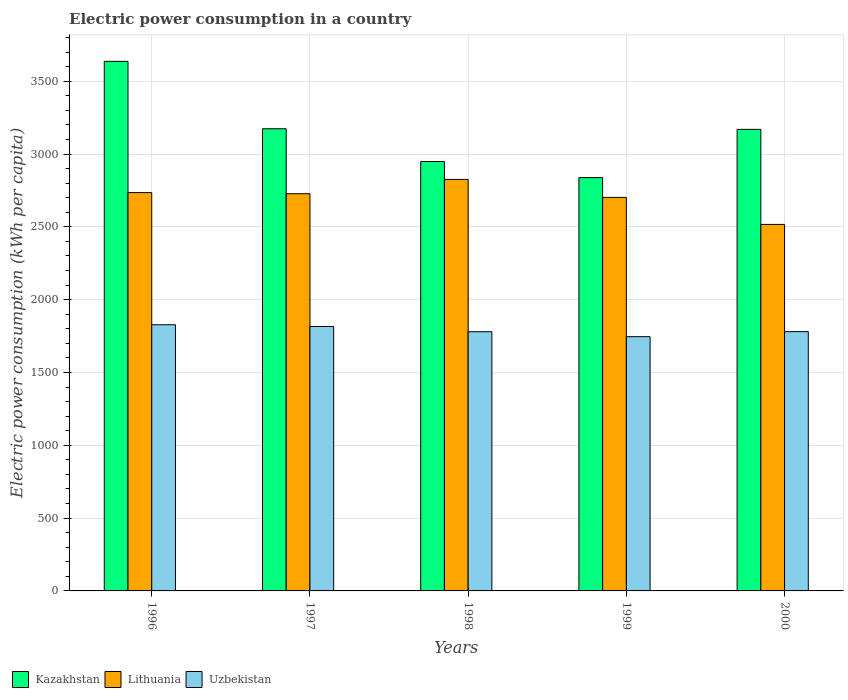How many different coloured bars are there?
Your answer should be very brief. 3. Are the number of bars per tick equal to the number of legend labels?
Your response must be concise. Yes. Are the number of bars on each tick of the X-axis equal?
Give a very brief answer. Yes. How many bars are there on the 5th tick from the left?
Provide a short and direct response. 3. What is the label of the 2nd group of bars from the left?
Provide a short and direct response. 1997. What is the electric power consumption in in Uzbekistan in 2000?
Provide a short and direct response. 1780.46. Across all years, what is the maximum electric power consumption in in Lithuania?
Make the answer very short. 2825.88. Across all years, what is the minimum electric power consumption in in Lithuania?
Make the answer very short. 2516.91. In which year was the electric power consumption in in Kazakhstan maximum?
Keep it short and to the point. 1996. What is the total electric power consumption in in Uzbekistan in the graph?
Give a very brief answer. 8949.89. What is the difference between the electric power consumption in in Kazakhstan in 1997 and that in 1998?
Your response must be concise. 225.01. What is the difference between the electric power consumption in in Lithuania in 1997 and the electric power consumption in in Kazakhstan in 1998?
Provide a short and direct response. -221.06. What is the average electric power consumption in in Lithuania per year?
Keep it short and to the point. 2701.68. In the year 1999, what is the difference between the electric power consumption in in Lithuania and electric power consumption in in Uzbekistan?
Give a very brief answer. 956.48. What is the ratio of the electric power consumption in in Lithuania in 1996 to that in 1999?
Offer a terse response. 1.01. Is the electric power consumption in in Kazakhstan in 1997 less than that in 1998?
Make the answer very short. No. Is the difference between the electric power consumption in in Lithuania in 1996 and 1997 greater than the difference between the electric power consumption in in Uzbekistan in 1996 and 1997?
Keep it short and to the point. No. What is the difference between the highest and the second highest electric power consumption in in Lithuania?
Provide a succinct answer. 90.44. What is the difference between the highest and the lowest electric power consumption in in Kazakhstan?
Your response must be concise. 798.28. Is the sum of the electric power consumption in in Uzbekistan in 1997 and 1999 greater than the maximum electric power consumption in in Lithuania across all years?
Ensure brevity in your answer.  Yes. What does the 3rd bar from the left in 1999 represents?
Your response must be concise. Uzbekistan. What does the 2nd bar from the right in 1998 represents?
Keep it short and to the point. Lithuania. Is it the case that in every year, the sum of the electric power consumption in in Kazakhstan and electric power consumption in in Uzbekistan is greater than the electric power consumption in in Lithuania?
Provide a short and direct response. Yes. How many bars are there?
Ensure brevity in your answer.  15. Are all the bars in the graph horizontal?
Give a very brief answer. No. Does the graph contain grids?
Offer a very short reply. Yes. How are the legend labels stacked?
Your answer should be very brief. Horizontal. What is the title of the graph?
Provide a short and direct response. Electric power consumption in a country. Does "Dominica" appear as one of the legend labels in the graph?
Ensure brevity in your answer.  No. What is the label or title of the Y-axis?
Ensure brevity in your answer.  Electric power consumption (kWh per capita). What is the Electric power consumption (kWh per capita) of Kazakhstan in 1996?
Make the answer very short. 3636.63. What is the Electric power consumption (kWh per capita) in Lithuania in 1996?
Your answer should be very brief. 2735.44. What is the Electric power consumption (kWh per capita) in Uzbekistan in 1996?
Your answer should be very brief. 1827.77. What is the Electric power consumption (kWh per capita) in Kazakhstan in 1997?
Make the answer very short. 3173.79. What is the Electric power consumption (kWh per capita) of Lithuania in 1997?
Offer a terse response. 2727.73. What is the Electric power consumption (kWh per capita) of Uzbekistan in 1997?
Your answer should be very brief. 1815.82. What is the Electric power consumption (kWh per capita) of Kazakhstan in 1998?
Ensure brevity in your answer.  2948.78. What is the Electric power consumption (kWh per capita) of Lithuania in 1998?
Keep it short and to the point. 2825.88. What is the Electric power consumption (kWh per capita) of Uzbekistan in 1998?
Your answer should be compact. 1779.88. What is the Electric power consumption (kWh per capita) in Kazakhstan in 1999?
Make the answer very short. 2838.34. What is the Electric power consumption (kWh per capita) in Lithuania in 1999?
Offer a very short reply. 2702.43. What is the Electric power consumption (kWh per capita) in Uzbekistan in 1999?
Your answer should be compact. 1745.95. What is the Electric power consumption (kWh per capita) of Kazakhstan in 2000?
Provide a short and direct response. 3169.52. What is the Electric power consumption (kWh per capita) in Lithuania in 2000?
Provide a short and direct response. 2516.91. What is the Electric power consumption (kWh per capita) in Uzbekistan in 2000?
Your response must be concise. 1780.46. Across all years, what is the maximum Electric power consumption (kWh per capita) of Kazakhstan?
Ensure brevity in your answer.  3636.63. Across all years, what is the maximum Electric power consumption (kWh per capita) in Lithuania?
Your answer should be very brief. 2825.88. Across all years, what is the maximum Electric power consumption (kWh per capita) in Uzbekistan?
Offer a terse response. 1827.77. Across all years, what is the minimum Electric power consumption (kWh per capita) of Kazakhstan?
Your response must be concise. 2838.34. Across all years, what is the minimum Electric power consumption (kWh per capita) in Lithuania?
Offer a very short reply. 2516.91. Across all years, what is the minimum Electric power consumption (kWh per capita) of Uzbekistan?
Offer a terse response. 1745.95. What is the total Electric power consumption (kWh per capita) in Kazakhstan in the graph?
Offer a very short reply. 1.58e+04. What is the total Electric power consumption (kWh per capita) in Lithuania in the graph?
Offer a terse response. 1.35e+04. What is the total Electric power consumption (kWh per capita) in Uzbekistan in the graph?
Your answer should be compact. 8949.89. What is the difference between the Electric power consumption (kWh per capita) in Kazakhstan in 1996 and that in 1997?
Offer a terse response. 462.83. What is the difference between the Electric power consumption (kWh per capita) in Lithuania in 1996 and that in 1997?
Your answer should be compact. 7.71. What is the difference between the Electric power consumption (kWh per capita) in Uzbekistan in 1996 and that in 1997?
Ensure brevity in your answer.  11.95. What is the difference between the Electric power consumption (kWh per capita) in Kazakhstan in 1996 and that in 1998?
Your response must be concise. 687.84. What is the difference between the Electric power consumption (kWh per capita) of Lithuania in 1996 and that in 1998?
Make the answer very short. -90.44. What is the difference between the Electric power consumption (kWh per capita) of Uzbekistan in 1996 and that in 1998?
Keep it short and to the point. 47.89. What is the difference between the Electric power consumption (kWh per capita) of Kazakhstan in 1996 and that in 1999?
Your answer should be very brief. 798.28. What is the difference between the Electric power consumption (kWh per capita) of Lithuania in 1996 and that in 1999?
Your answer should be very brief. 33.01. What is the difference between the Electric power consumption (kWh per capita) of Uzbekistan in 1996 and that in 1999?
Provide a short and direct response. 81.82. What is the difference between the Electric power consumption (kWh per capita) of Kazakhstan in 1996 and that in 2000?
Offer a terse response. 467.1. What is the difference between the Electric power consumption (kWh per capita) of Lithuania in 1996 and that in 2000?
Your answer should be very brief. 218.54. What is the difference between the Electric power consumption (kWh per capita) of Uzbekistan in 1996 and that in 2000?
Make the answer very short. 47.31. What is the difference between the Electric power consumption (kWh per capita) in Kazakhstan in 1997 and that in 1998?
Your answer should be compact. 225.01. What is the difference between the Electric power consumption (kWh per capita) in Lithuania in 1997 and that in 1998?
Your answer should be very brief. -98.16. What is the difference between the Electric power consumption (kWh per capita) of Uzbekistan in 1997 and that in 1998?
Provide a succinct answer. 35.94. What is the difference between the Electric power consumption (kWh per capita) of Kazakhstan in 1997 and that in 1999?
Provide a short and direct response. 335.45. What is the difference between the Electric power consumption (kWh per capita) in Lithuania in 1997 and that in 1999?
Your answer should be very brief. 25.3. What is the difference between the Electric power consumption (kWh per capita) in Uzbekistan in 1997 and that in 1999?
Your response must be concise. 69.87. What is the difference between the Electric power consumption (kWh per capita) in Kazakhstan in 1997 and that in 2000?
Your answer should be very brief. 4.27. What is the difference between the Electric power consumption (kWh per capita) in Lithuania in 1997 and that in 2000?
Your answer should be compact. 210.82. What is the difference between the Electric power consumption (kWh per capita) of Uzbekistan in 1997 and that in 2000?
Keep it short and to the point. 35.36. What is the difference between the Electric power consumption (kWh per capita) of Kazakhstan in 1998 and that in 1999?
Your response must be concise. 110.44. What is the difference between the Electric power consumption (kWh per capita) in Lithuania in 1998 and that in 1999?
Make the answer very short. 123.46. What is the difference between the Electric power consumption (kWh per capita) of Uzbekistan in 1998 and that in 1999?
Ensure brevity in your answer.  33.93. What is the difference between the Electric power consumption (kWh per capita) in Kazakhstan in 1998 and that in 2000?
Your answer should be compact. -220.74. What is the difference between the Electric power consumption (kWh per capita) of Lithuania in 1998 and that in 2000?
Provide a short and direct response. 308.98. What is the difference between the Electric power consumption (kWh per capita) in Uzbekistan in 1998 and that in 2000?
Your answer should be compact. -0.57. What is the difference between the Electric power consumption (kWh per capita) in Kazakhstan in 1999 and that in 2000?
Give a very brief answer. -331.18. What is the difference between the Electric power consumption (kWh per capita) of Lithuania in 1999 and that in 2000?
Offer a terse response. 185.52. What is the difference between the Electric power consumption (kWh per capita) of Uzbekistan in 1999 and that in 2000?
Offer a terse response. -34.5. What is the difference between the Electric power consumption (kWh per capita) of Kazakhstan in 1996 and the Electric power consumption (kWh per capita) of Lithuania in 1997?
Provide a succinct answer. 908.9. What is the difference between the Electric power consumption (kWh per capita) of Kazakhstan in 1996 and the Electric power consumption (kWh per capita) of Uzbekistan in 1997?
Offer a very short reply. 1820.81. What is the difference between the Electric power consumption (kWh per capita) in Lithuania in 1996 and the Electric power consumption (kWh per capita) in Uzbekistan in 1997?
Your answer should be compact. 919.62. What is the difference between the Electric power consumption (kWh per capita) in Kazakhstan in 1996 and the Electric power consumption (kWh per capita) in Lithuania in 1998?
Offer a very short reply. 810.74. What is the difference between the Electric power consumption (kWh per capita) in Kazakhstan in 1996 and the Electric power consumption (kWh per capita) in Uzbekistan in 1998?
Give a very brief answer. 1856.74. What is the difference between the Electric power consumption (kWh per capita) in Lithuania in 1996 and the Electric power consumption (kWh per capita) in Uzbekistan in 1998?
Give a very brief answer. 955.56. What is the difference between the Electric power consumption (kWh per capita) in Kazakhstan in 1996 and the Electric power consumption (kWh per capita) in Lithuania in 1999?
Ensure brevity in your answer.  934.2. What is the difference between the Electric power consumption (kWh per capita) in Kazakhstan in 1996 and the Electric power consumption (kWh per capita) in Uzbekistan in 1999?
Offer a terse response. 1890.67. What is the difference between the Electric power consumption (kWh per capita) of Lithuania in 1996 and the Electric power consumption (kWh per capita) of Uzbekistan in 1999?
Offer a very short reply. 989.49. What is the difference between the Electric power consumption (kWh per capita) in Kazakhstan in 1996 and the Electric power consumption (kWh per capita) in Lithuania in 2000?
Keep it short and to the point. 1119.72. What is the difference between the Electric power consumption (kWh per capita) in Kazakhstan in 1996 and the Electric power consumption (kWh per capita) in Uzbekistan in 2000?
Make the answer very short. 1856.17. What is the difference between the Electric power consumption (kWh per capita) in Lithuania in 1996 and the Electric power consumption (kWh per capita) in Uzbekistan in 2000?
Offer a very short reply. 954.98. What is the difference between the Electric power consumption (kWh per capita) in Kazakhstan in 1997 and the Electric power consumption (kWh per capita) in Lithuania in 1998?
Your answer should be very brief. 347.91. What is the difference between the Electric power consumption (kWh per capita) of Kazakhstan in 1997 and the Electric power consumption (kWh per capita) of Uzbekistan in 1998?
Your response must be concise. 1393.91. What is the difference between the Electric power consumption (kWh per capita) of Lithuania in 1997 and the Electric power consumption (kWh per capita) of Uzbekistan in 1998?
Keep it short and to the point. 947.84. What is the difference between the Electric power consumption (kWh per capita) in Kazakhstan in 1997 and the Electric power consumption (kWh per capita) in Lithuania in 1999?
Make the answer very short. 471.36. What is the difference between the Electric power consumption (kWh per capita) in Kazakhstan in 1997 and the Electric power consumption (kWh per capita) in Uzbekistan in 1999?
Offer a terse response. 1427.84. What is the difference between the Electric power consumption (kWh per capita) in Lithuania in 1997 and the Electric power consumption (kWh per capita) in Uzbekistan in 1999?
Offer a terse response. 981.77. What is the difference between the Electric power consumption (kWh per capita) of Kazakhstan in 1997 and the Electric power consumption (kWh per capita) of Lithuania in 2000?
Offer a terse response. 656.89. What is the difference between the Electric power consumption (kWh per capita) of Kazakhstan in 1997 and the Electric power consumption (kWh per capita) of Uzbekistan in 2000?
Provide a short and direct response. 1393.34. What is the difference between the Electric power consumption (kWh per capita) of Lithuania in 1997 and the Electric power consumption (kWh per capita) of Uzbekistan in 2000?
Your answer should be very brief. 947.27. What is the difference between the Electric power consumption (kWh per capita) in Kazakhstan in 1998 and the Electric power consumption (kWh per capita) in Lithuania in 1999?
Offer a very short reply. 246.36. What is the difference between the Electric power consumption (kWh per capita) in Kazakhstan in 1998 and the Electric power consumption (kWh per capita) in Uzbekistan in 1999?
Your answer should be very brief. 1202.83. What is the difference between the Electric power consumption (kWh per capita) of Lithuania in 1998 and the Electric power consumption (kWh per capita) of Uzbekistan in 1999?
Offer a terse response. 1079.93. What is the difference between the Electric power consumption (kWh per capita) in Kazakhstan in 1998 and the Electric power consumption (kWh per capita) in Lithuania in 2000?
Offer a terse response. 431.88. What is the difference between the Electric power consumption (kWh per capita) of Kazakhstan in 1998 and the Electric power consumption (kWh per capita) of Uzbekistan in 2000?
Give a very brief answer. 1168.33. What is the difference between the Electric power consumption (kWh per capita) in Lithuania in 1998 and the Electric power consumption (kWh per capita) in Uzbekistan in 2000?
Offer a terse response. 1045.43. What is the difference between the Electric power consumption (kWh per capita) of Kazakhstan in 1999 and the Electric power consumption (kWh per capita) of Lithuania in 2000?
Make the answer very short. 321.44. What is the difference between the Electric power consumption (kWh per capita) of Kazakhstan in 1999 and the Electric power consumption (kWh per capita) of Uzbekistan in 2000?
Make the answer very short. 1057.89. What is the difference between the Electric power consumption (kWh per capita) of Lithuania in 1999 and the Electric power consumption (kWh per capita) of Uzbekistan in 2000?
Provide a succinct answer. 921.97. What is the average Electric power consumption (kWh per capita) of Kazakhstan per year?
Ensure brevity in your answer.  3153.41. What is the average Electric power consumption (kWh per capita) in Lithuania per year?
Provide a short and direct response. 2701.68. What is the average Electric power consumption (kWh per capita) of Uzbekistan per year?
Provide a succinct answer. 1789.98. In the year 1996, what is the difference between the Electric power consumption (kWh per capita) of Kazakhstan and Electric power consumption (kWh per capita) of Lithuania?
Provide a succinct answer. 901.19. In the year 1996, what is the difference between the Electric power consumption (kWh per capita) in Kazakhstan and Electric power consumption (kWh per capita) in Uzbekistan?
Offer a very short reply. 1808.86. In the year 1996, what is the difference between the Electric power consumption (kWh per capita) in Lithuania and Electric power consumption (kWh per capita) in Uzbekistan?
Offer a terse response. 907.67. In the year 1997, what is the difference between the Electric power consumption (kWh per capita) of Kazakhstan and Electric power consumption (kWh per capita) of Lithuania?
Give a very brief answer. 446.07. In the year 1997, what is the difference between the Electric power consumption (kWh per capita) in Kazakhstan and Electric power consumption (kWh per capita) in Uzbekistan?
Offer a terse response. 1357.97. In the year 1997, what is the difference between the Electric power consumption (kWh per capita) of Lithuania and Electric power consumption (kWh per capita) of Uzbekistan?
Provide a succinct answer. 911.91. In the year 1998, what is the difference between the Electric power consumption (kWh per capita) of Kazakhstan and Electric power consumption (kWh per capita) of Lithuania?
Provide a succinct answer. 122.9. In the year 1998, what is the difference between the Electric power consumption (kWh per capita) in Kazakhstan and Electric power consumption (kWh per capita) in Uzbekistan?
Give a very brief answer. 1168.9. In the year 1998, what is the difference between the Electric power consumption (kWh per capita) of Lithuania and Electric power consumption (kWh per capita) of Uzbekistan?
Offer a terse response. 1046. In the year 1999, what is the difference between the Electric power consumption (kWh per capita) of Kazakhstan and Electric power consumption (kWh per capita) of Lithuania?
Make the answer very short. 135.92. In the year 1999, what is the difference between the Electric power consumption (kWh per capita) of Kazakhstan and Electric power consumption (kWh per capita) of Uzbekistan?
Provide a short and direct response. 1092.39. In the year 1999, what is the difference between the Electric power consumption (kWh per capita) in Lithuania and Electric power consumption (kWh per capita) in Uzbekistan?
Offer a very short reply. 956.48. In the year 2000, what is the difference between the Electric power consumption (kWh per capita) of Kazakhstan and Electric power consumption (kWh per capita) of Lithuania?
Your response must be concise. 652.62. In the year 2000, what is the difference between the Electric power consumption (kWh per capita) in Kazakhstan and Electric power consumption (kWh per capita) in Uzbekistan?
Make the answer very short. 1389.07. In the year 2000, what is the difference between the Electric power consumption (kWh per capita) in Lithuania and Electric power consumption (kWh per capita) in Uzbekistan?
Your answer should be compact. 736.45. What is the ratio of the Electric power consumption (kWh per capita) in Kazakhstan in 1996 to that in 1997?
Your answer should be very brief. 1.15. What is the ratio of the Electric power consumption (kWh per capita) of Lithuania in 1996 to that in 1997?
Ensure brevity in your answer.  1. What is the ratio of the Electric power consumption (kWh per capita) in Uzbekistan in 1996 to that in 1997?
Provide a short and direct response. 1.01. What is the ratio of the Electric power consumption (kWh per capita) in Kazakhstan in 1996 to that in 1998?
Make the answer very short. 1.23. What is the ratio of the Electric power consumption (kWh per capita) of Uzbekistan in 1996 to that in 1998?
Make the answer very short. 1.03. What is the ratio of the Electric power consumption (kWh per capita) of Kazakhstan in 1996 to that in 1999?
Give a very brief answer. 1.28. What is the ratio of the Electric power consumption (kWh per capita) in Lithuania in 1996 to that in 1999?
Keep it short and to the point. 1.01. What is the ratio of the Electric power consumption (kWh per capita) in Uzbekistan in 1996 to that in 1999?
Your answer should be very brief. 1.05. What is the ratio of the Electric power consumption (kWh per capita) in Kazakhstan in 1996 to that in 2000?
Make the answer very short. 1.15. What is the ratio of the Electric power consumption (kWh per capita) in Lithuania in 1996 to that in 2000?
Offer a very short reply. 1.09. What is the ratio of the Electric power consumption (kWh per capita) in Uzbekistan in 1996 to that in 2000?
Make the answer very short. 1.03. What is the ratio of the Electric power consumption (kWh per capita) in Kazakhstan in 1997 to that in 1998?
Your answer should be very brief. 1.08. What is the ratio of the Electric power consumption (kWh per capita) in Lithuania in 1997 to that in 1998?
Provide a succinct answer. 0.97. What is the ratio of the Electric power consumption (kWh per capita) of Uzbekistan in 1997 to that in 1998?
Provide a short and direct response. 1.02. What is the ratio of the Electric power consumption (kWh per capita) in Kazakhstan in 1997 to that in 1999?
Give a very brief answer. 1.12. What is the ratio of the Electric power consumption (kWh per capita) of Lithuania in 1997 to that in 1999?
Provide a succinct answer. 1.01. What is the ratio of the Electric power consumption (kWh per capita) in Uzbekistan in 1997 to that in 1999?
Your response must be concise. 1.04. What is the ratio of the Electric power consumption (kWh per capita) of Lithuania in 1997 to that in 2000?
Keep it short and to the point. 1.08. What is the ratio of the Electric power consumption (kWh per capita) in Uzbekistan in 1997 to that in 2000?
Ensure brevity in your answer.  1.02. What is the ratio of the Electric power consumption (kWh per capita) of Kazakhstan in 1998 to that in 1999?
Your answer should be compact. 1.04. What is the ratio of the Electric power consumption (kWh per capita) of Lithuania in 1998 to that in 1999?
Provide a succinct answer. 1.05. What is the ratio of the Electric power consumption (kWh per capita) in Uzbekistan in 1998 to that in 1999?
Give a very brief answer. 1.02. What is the ratio of the Electric power consumption (kWh per capita) of Kazakhstan in 1998 to that in 2000?
Your response must be concise. 0.93. What is the ratio of the Electric power consumption (kWh per capita) in Lithuania in 1998 to that in 2000?
Make the answer very short. 1.12. What is the ratio of the Electric power consumption (kWh per capita) of Kazakhstan in 1999 to that in 2000?
Your answer should be compact. 0.9. What is the ratio of the Electric power consumption (kWh per capita) in Lithuania in 1999 to that in 2000?
Offer a very short reply. 1.07. What is the ratio of the Electric power consumption (kWh per capita) in Uzbekistan in 1999 to that in 2000?
Offer a very short reply. 0.98. What is the difference between the highest and the second highest Electric power consumption (kWh per capita) of Kazakhstan?
Your answer should be compact. 462.83. What is the difference between the highest and the second highest Electric power consumption (kWh per capita) in Lithuania?
Provide a succinct answer. 90.44. What is the difference between the highest and the second highest Electric power consumption (kWh per capita) in Uzbekistan?
Offer a terse response. 11.95. What is the difference between the highest and the lowest Electric power consumption (kWh per capita) of Kazakhstan?
Keep it short and to the point. 798.28. What is the difference between the highest and the lowest Electric power consumption (kWh per capita) of Lithuania?
Your answer should be very brief. 308.98. What is the difference between the highest and the lowest Electric power consumption (kWh per capita) in Uzbekistan?
Your response must be concise. 81.82. 